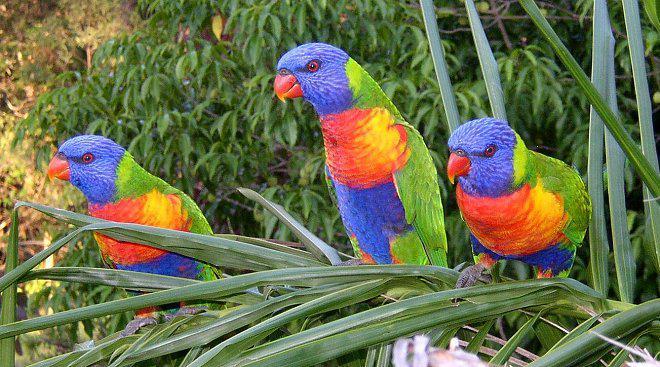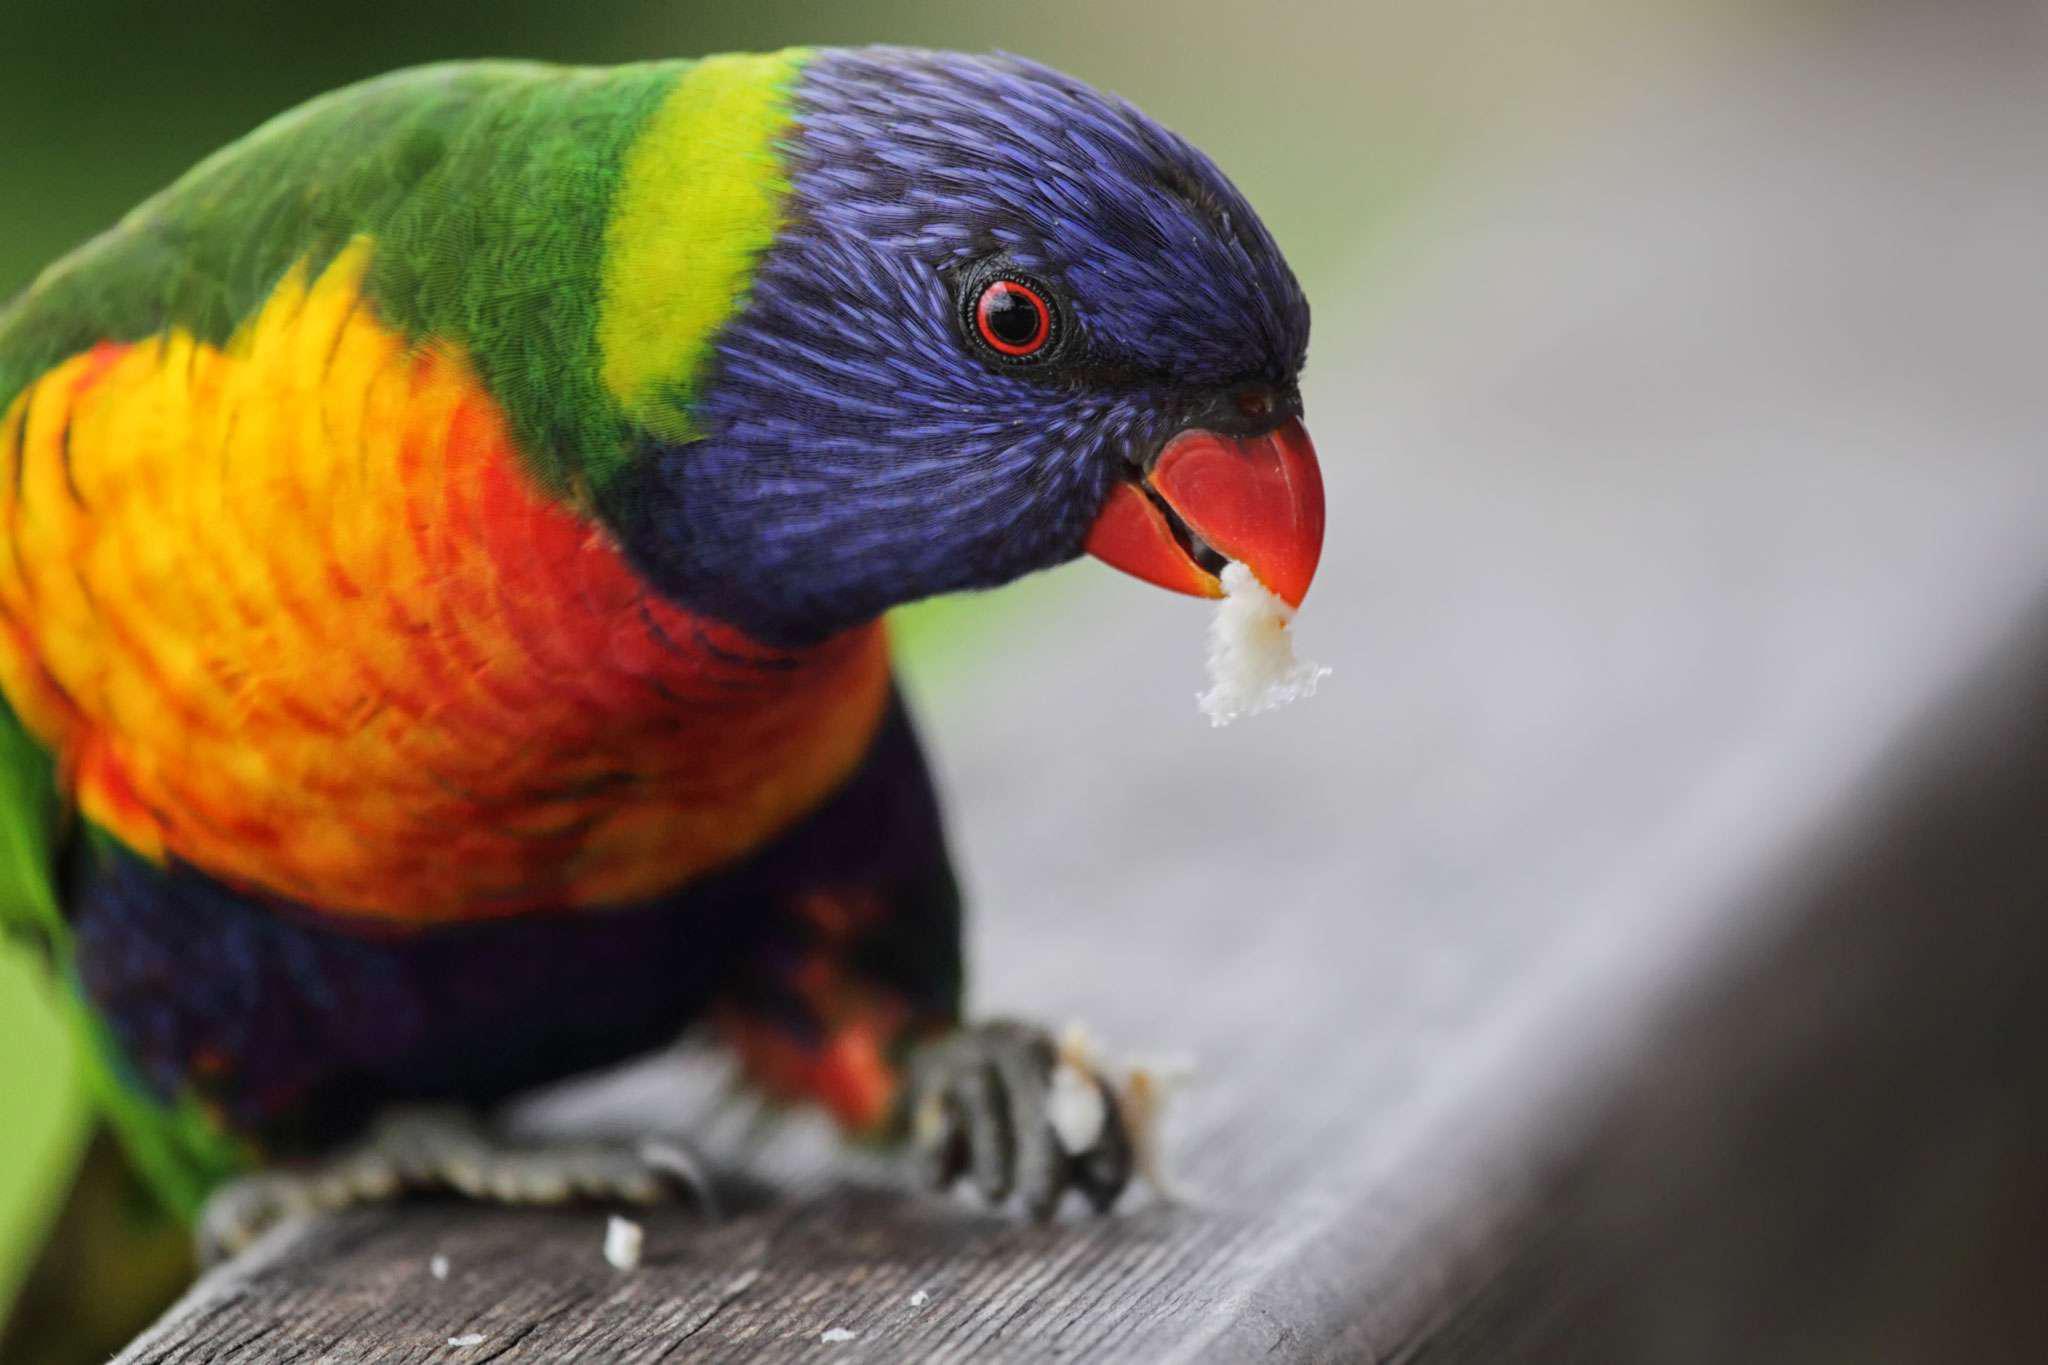The first image is the image on the left, the second image is the image on the right. Examine the images to the left and right. Is the description "All birds are alone." accurate? Answer yes or no. No. 